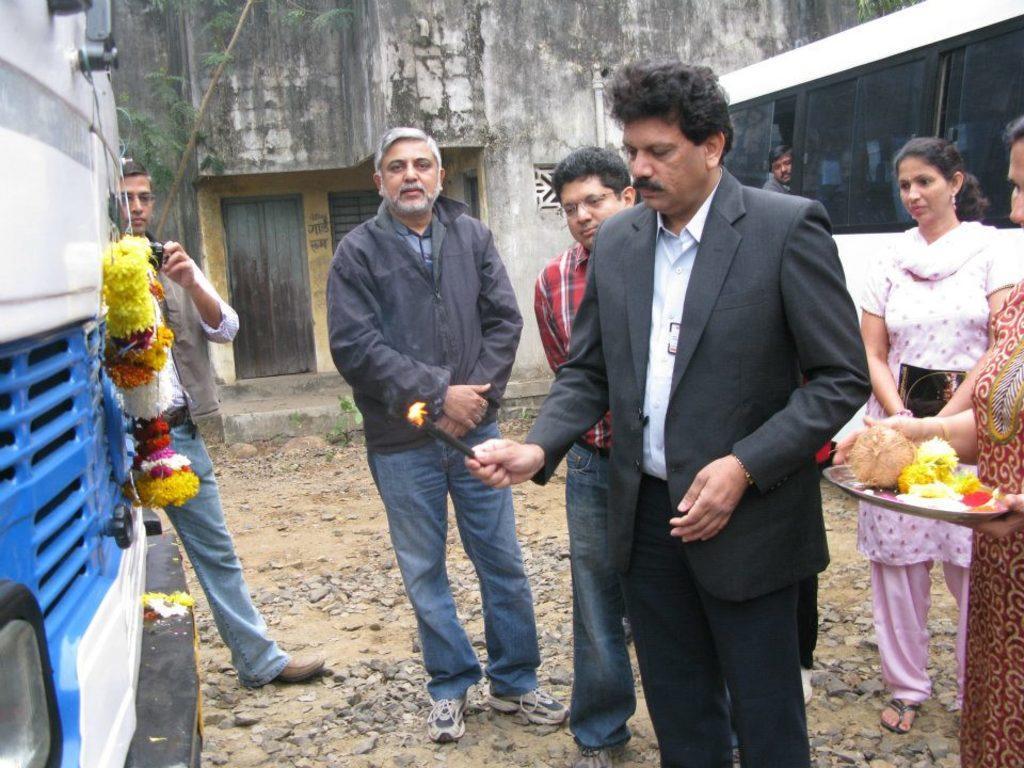In one or two sentences, can you explain what this image depicts? In the image there is a man inaugurating a vehicle and around him there are some other people and in the background there is a wall and in front of the wall there is a bus. 